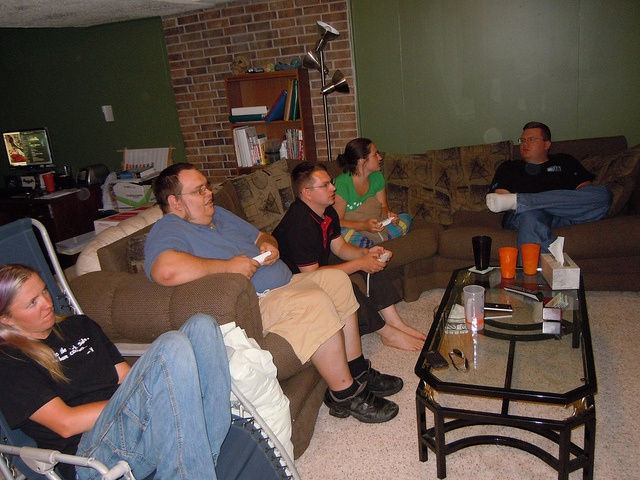Describe the objects in this image and their specific colors. I can see couch in gray, black, maroon, and brown tones, people in gray, black, and darkgray tones, people in gray, tan, black, and salmon tones, chair in gray, black, and darkgray tones, and people in gray, black, brown, and maroon tones in this image. 